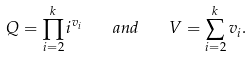Convert formula to latex. <formula><loc_0><loc_0><loc_500><loc_500>Q = \prod _ { i = 2 } ^ { k } i ^ { v _ { i } } \quad a n d \quad V = \sum _ { i = 2 } ^ { k } v _ { i } .</formula> 